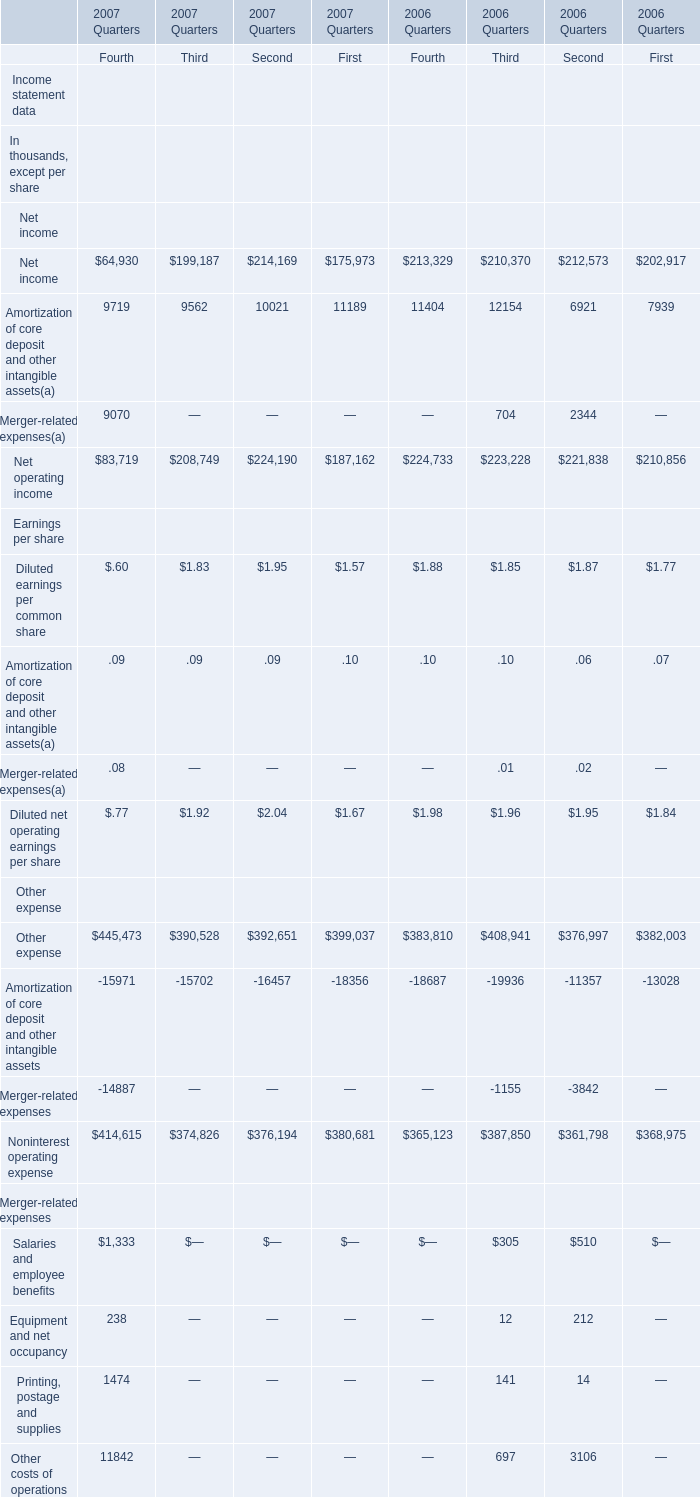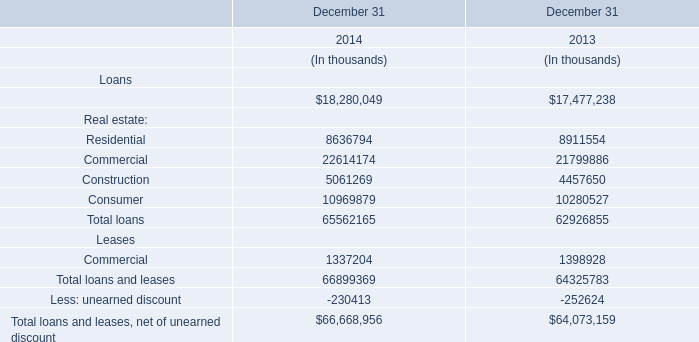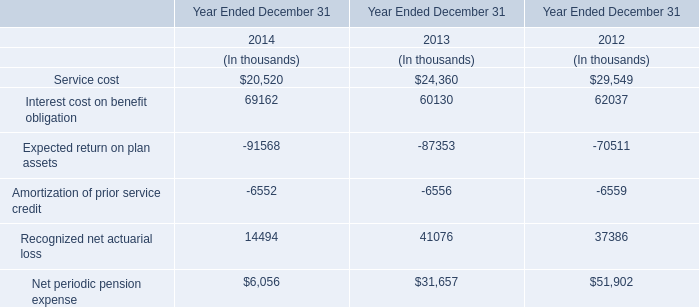What was the total amount of the Other costs of operations in the Quarter of 2006 where the Salaries and employee benefits is greater than 500 thousand? (in thousand) 
Answer: 3106. What's the sum of the Amortization of prior service credit in the years where Total loans for loans is positive? (in thousand) 
Computations: (-6552 - 6556)
Answer: -13108.0. What is the sum of the Printing, postage and supplies, the Salaries and employee benefits and the Equipment and net occupancy for the Third Quarter in 2006? (in thousand) 
Computations: ((141 + 305) + 12)
Answer: 458.0. 